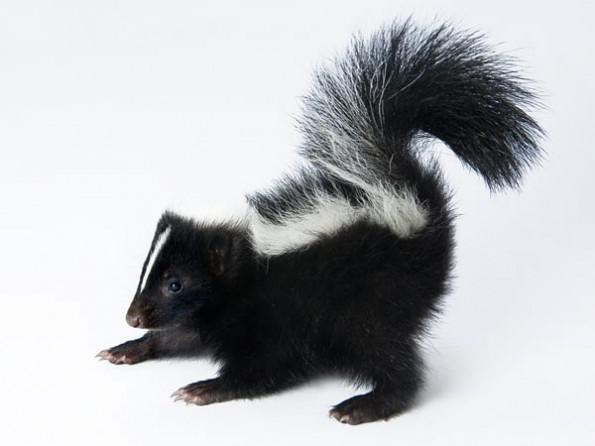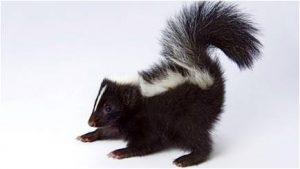The first image is the image on the left, the second image is the image on the right. For the images displayed, is the sentence "The left and right image contains the same number of live skunks with at least one sitting on a white floor." factually correct? Answer yes or no. Yes. 